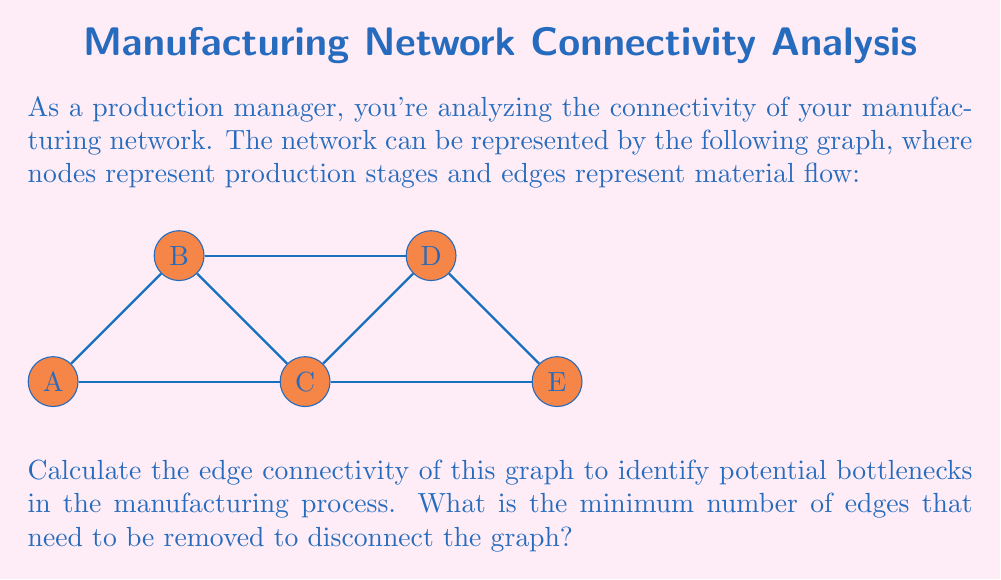Help me with this question. To solve this problem, we need to understand the concept of edge connectivity in graph theory and apply it to our manufacturing network.

1. Edge connectivity is defined as the minimum number of edges that need to be removed to disconnect a graph.

2. To find the edge connectivity, we need to identify all possible cuts that would disconnect the graph and find the smallest one.

3. Let's analyze the possible cuts:
   a) Removing edges A-B and A-C disconnects A from the rest of the graph.
   b) Removing edges B-C and B-D disconnects B from the rest of the graph.
   c) Removing edges A-C, B-C, and C-D disconnects C from the rest of the graph.
   d) Removing edges B-D and C-D disconnects D from the rest of the graph.
   e) Removing edges C-E and D-E disconnects E from the rest of the graph.

4. The smallest cut among these is 2 edges, which can be achieved in multiple ways:
   - Removing A-B and A-C
   - Removing B-C and B-D
   - Removing C-E and D-E

5. Therefore, the edge connectivity of this graph is 2.

In terms of the manufacturing process, this means that there are multiple points where removing just two connections would create a bottleneck, potentially disrupting the entire production flow. These points (like the connections to nodes A, B, or E) should be considered critical in the production process and may require additional attention or redundancy to ensure smooth operations.
Answer: 2 